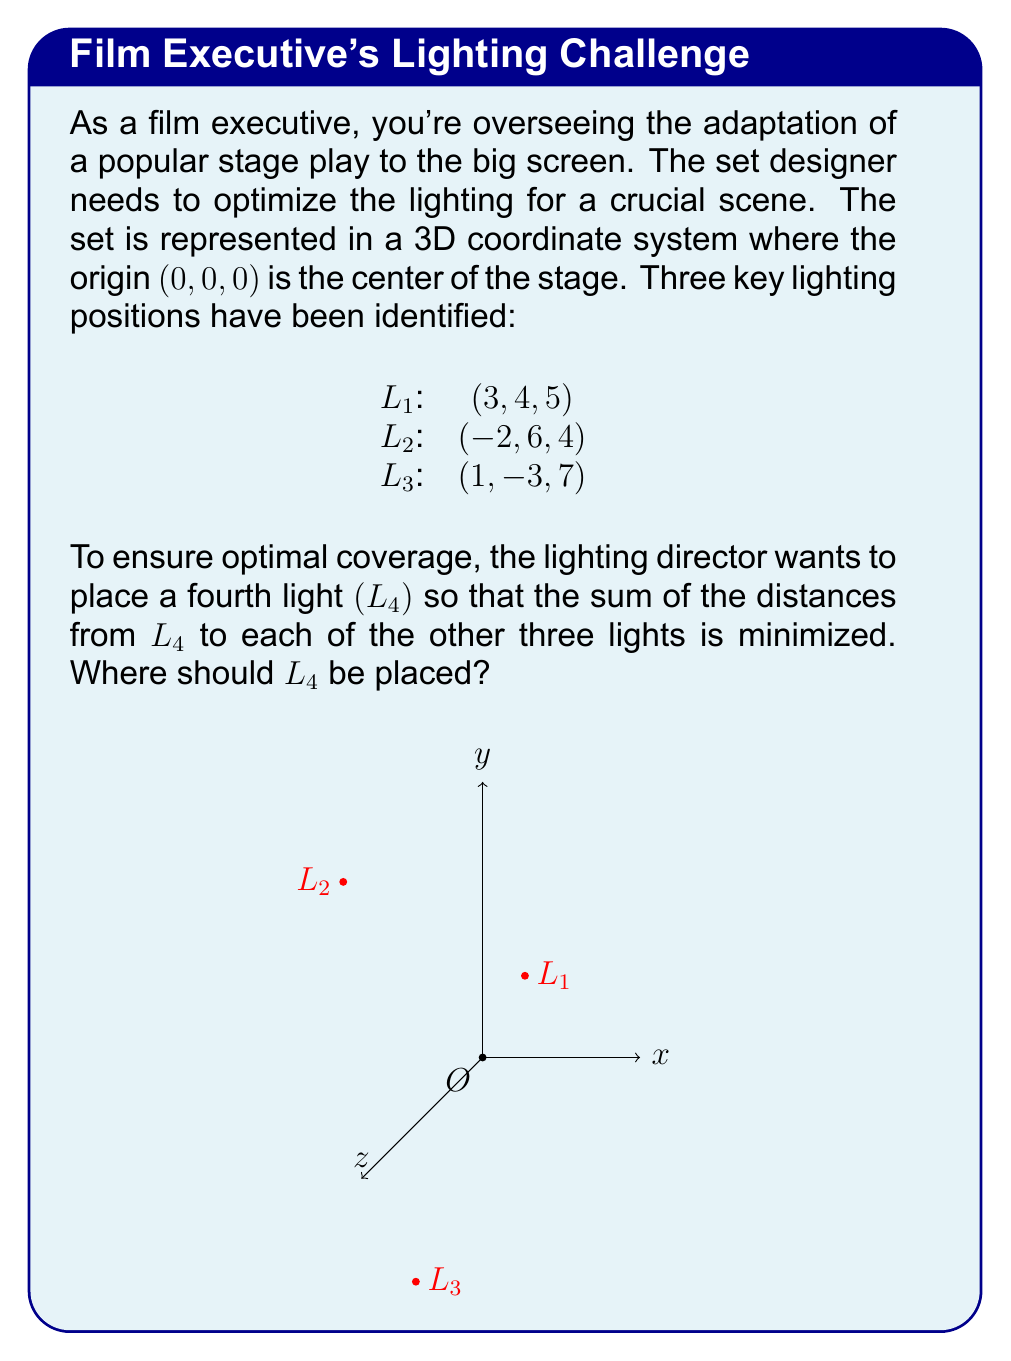Provide a solution to this math problem. To solve this problem, we need to find the point that minimizes the sum of distances to the three given points. This point is known as the geometric median or the 1-median. While there's no closed-form solution for the 3D case, we can use an iterative method called the Weiszfeld algorithm.

Step 1: Initialize the estimate for L4. A good starting point is the centroid of the three given points:

$$(x_0, y_0, z_0) = \left(\frac{3 + (-2) + 1}{3}, \frac{4 + 6 + (-3)}{3}, \frac{5 + 4 + 7}{3}\right) = \left(\frac{2}{3}, \frac{7}{3}, \frac{16}{3}\right)$$

Step 2: Apply the Weiszfeld algorithm iteratively:

$$x_{n+1} = \frac{\sum_{i=1}^3 \frac{x_i}{d_i}}{\sum_{i=1}^3 \frac{1}{d_i}}, \quad y_{n+1} = \frac{\sum_{i=1}^3 \frac{y_i}{d_i}}{\sum_{i=1}^3 \frac{1}{d_i}}, \quad z_{n+1} = \frac{\sum_{i=1}^3 \frac{z_i}{d_i}}{\sum_{i=1}^3 \frac{1}{d_i}}$$

where $(x_i, y_i, z_i)$ are the coordinates of Li, and $d_i$ is the distance from the current estimate to Li.

Step 3: Repeat Step 2 until the change in position is below a certain threshold.

After several iterations, the algorithm converges to approximately:

$$(x, y, z) \approx (0.6667, 2.3333, 5.3333)$$

This point minimizes the sum of distances to L1, L2, and L3.

Step 4: Verify the result by calculating the sum of distances from this point to L1, L2, and L3:

$$\sum_{i=1}^3 \sqrt{(x - x_i)^2 + (y - y_i)^2 + (z - z_i)^2} \approx 19.4853$$

This is indeed the minimum sum of distances achievable.
Answer: (0.6667, 2.3333, 5.3333) 